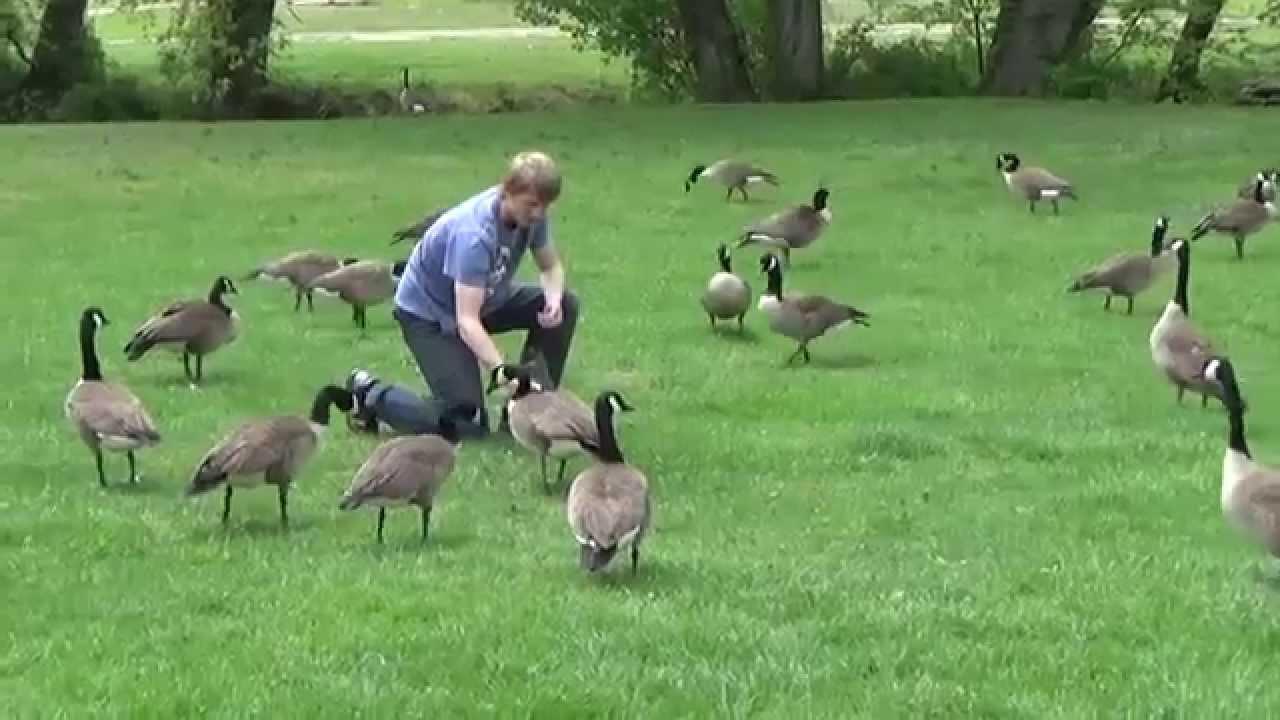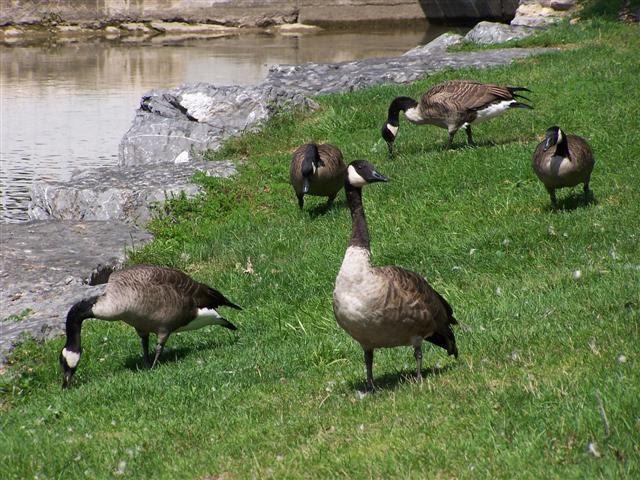The first image is the image on the left, the second image is the image on the right. For the images shown, is this caption "There is a man among a flock of geese in an outdoor setting" true? Answer yes or no. Yes. The first image is the image on the left, the second image is the image on the right. Examine the images to the left and right. Is the description "There is a person near the birds in one of the images." accurate? Answer yes or no. Yes. 